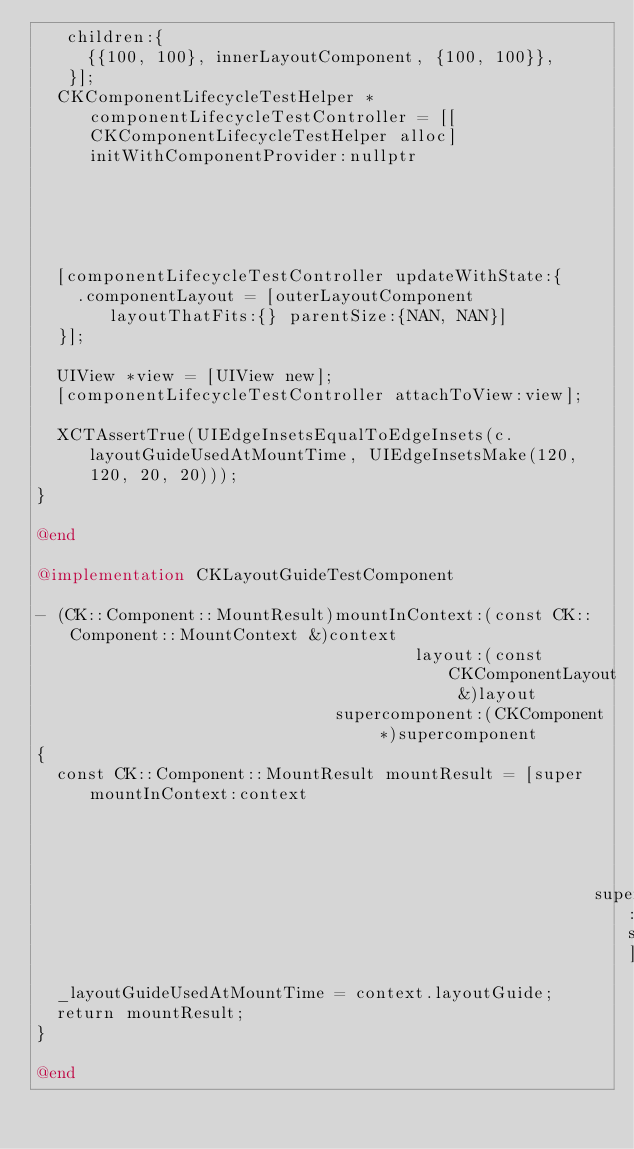Convert code to text. <code><loc_0><loc_0><loc_500><loc_500><_ObjectiveC_>   children:{
     {{100, 100}, innerLayoutComponent, {100, 100}},
   }];
  CKComponentLifecycleTestHelper *componentLifecycleTestController = [[CKComponentLifecycleTestHelper alloc] initWithComponentProvider:nullptr
                                                                                                                             sizeRangeProvider:nil];
  [componentLifecycleTestController updateWithState:{
    .componentLayout = [outerLayoutComponent layoutThatFits:{} parentSize:{NAN, NAN}]
  }];

  UIView *view = [UIView new];
  [componentLifecycleTestController attachToView:view];

  XCTAssertTrue(UIEdgeInsetsEqualToEdgeInsets(c.layoutGuideUsedAtMountTime, UIEdgeInsetsMake(120, 120, 20, 20)));
}

@end

@implementation CKLayoutGuideTestComponent

- (CK::Component::MountResult)mountInContext:(const CK::Component::MountContext &)context
                                      layout:(const CKComponentLayout &)layout
                              supercomponent:(CKComponent *)supercomponent
{
  const CK::Component::MountResult mountResult = [super mountInContext:context
                                                                layout:layout
                                                        supercomponent:supercomponent];
  _layoutGuideUsedAtMountTime = context.layoutGuide;
  return mountResult;
}

@end
</code> 